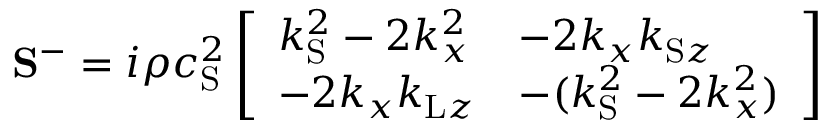<formula> <loc_0><loc_0><loc_500><loc_500>S ^ { - } = i \rho c _ { S } ^ { 2 } \left [ \begin{array} { l l } { k _ { S } ^ { 2 } - 2 k _ { x } ^ { 2 } } & { - 2 k _ { x } k _ { S z } } \\ { - 2 k _ { x } k _ { L z } } & { - ( k _ { S } ^ { 2 } - 2 k _ { x } ^ { 2 } ) } \end{array} \right ]</formula> 